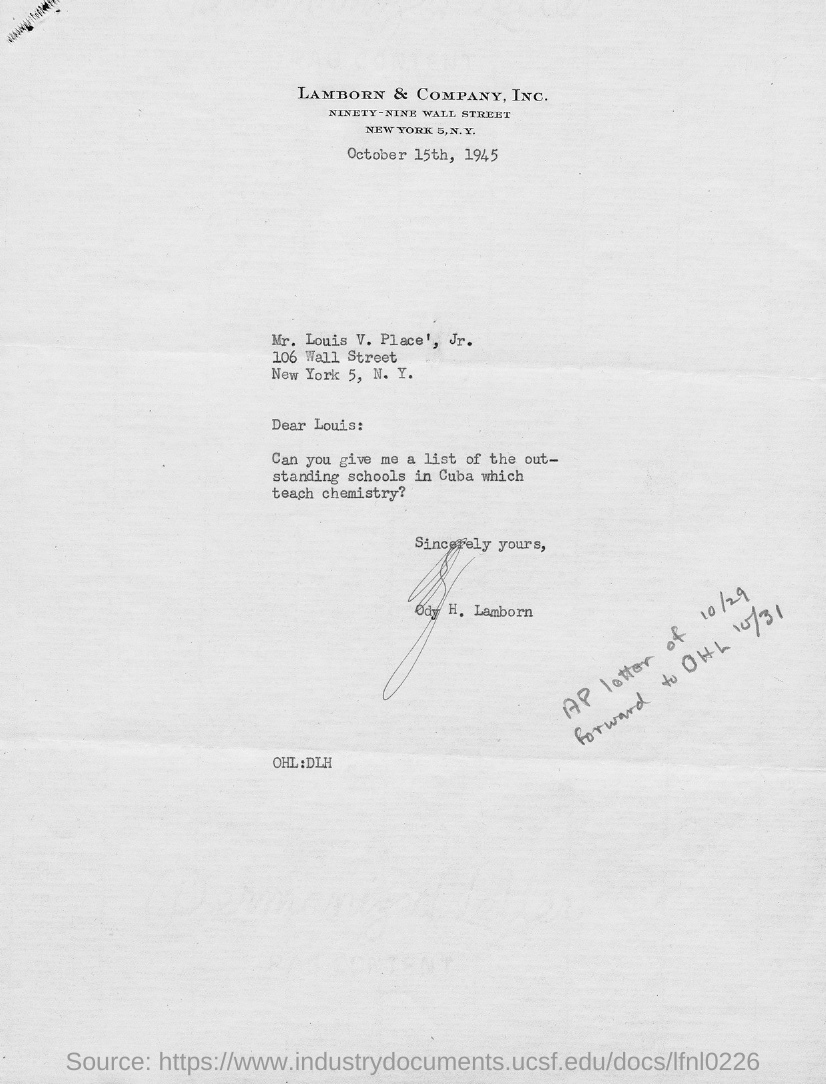What is the date on the document?
Offer a terse response. October 15th, 1945. To Whom is this letter addressed to?
Keep it short and to the point. Mr. Louis V. Place', Jr. A list of out-standing schools in Cuba which teach what?
Make the answer very short. Chemistry. Who is this letter from?
Offer a terse response. Ody h. lamborn. 